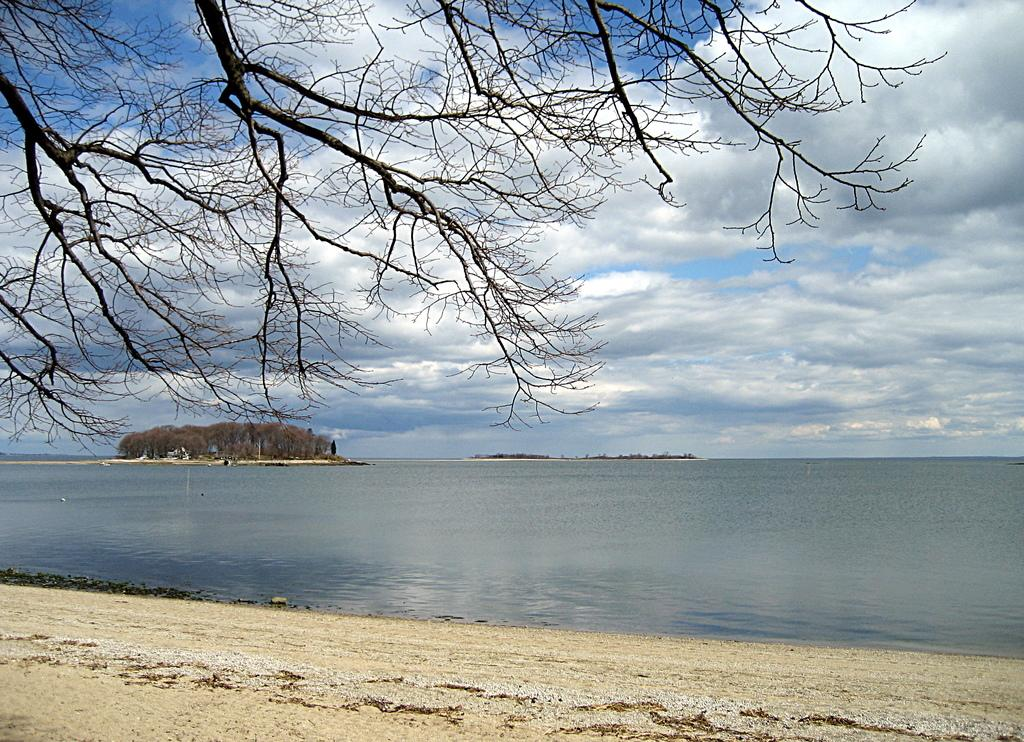What type of natural element can be seen in the image? There is a tree in the image. What is the primary substance visible in the image? There is water in the image. What is present at the bottom of the image? There is sand at the bottom of the image. What can be seen in the background of the image? There are trees and the sky visible in the background of the image. What is the condition of the sky in the image? The sky is visible in the background of the image, and there are clouds present. What type of vegetable is being harvested in the image? There is no vegetable being harvested in the image; it features a tree, water, sand, and a sky with clouds. 